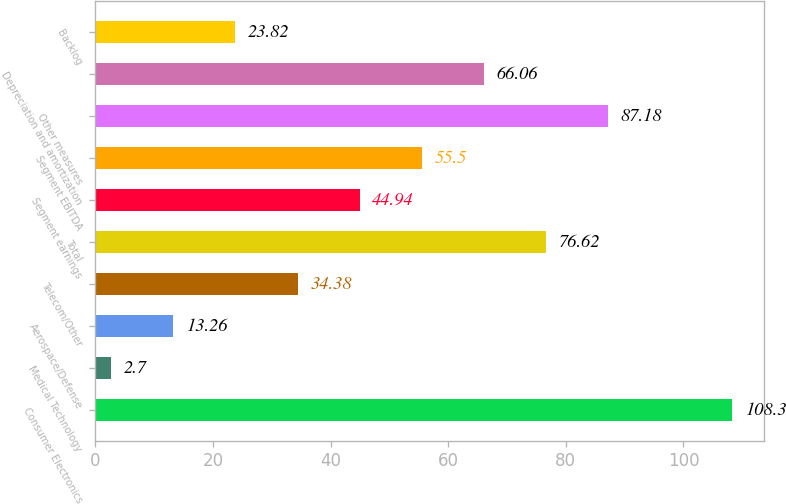Convert chart to OTSL. <chart><loc_0><loc_0><loc_500><loc_500><bar_chart><fcel>Consumer Electronics<fcel>Medical Technology<fcel>Aerospace/Defense<fcel>Telecom/Other<fcel>Total<fcel>Segment earnings<fcel>Segment EBITDA<fcel>Other measures<fcel>Depreciation and amortization<fcel>Backlog<nl><fcel>108.3<fcel>2.7<fcel>13.26<fcel>34.38<fcel>76.62<fcel>44.94<fcel>55.5<fcel>87.18<fcel>66.06<fcel>23.82<nl></chart> 